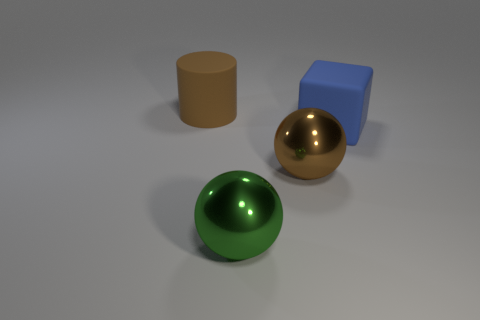Add 4 big cylinders. How many objects exist? 8 Subtract all green balls. How many balls are left? 1 Subtract all blocks. How many objects are left? 3 Add 2 brown rubber objects. How many brown rubber objects are left? 3 Add 3 small blue blocks. How many small blue blocks exist? 3 Subtract 0 gray spheres. How many objects are left? 4 Subtract 1 balls. How many balls are left? 1 Subtract all green balls. Subtract all red cubes. How many balls are left? 1 Subtract all cyan cylinders. How many brown spheres are left? 1 Subtract all big blue things. Subtract all big brown cylinders. How many objects are left? 2 